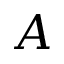<formula> <loc_0><loc_0><loc_500><loc_500>A</formula> 